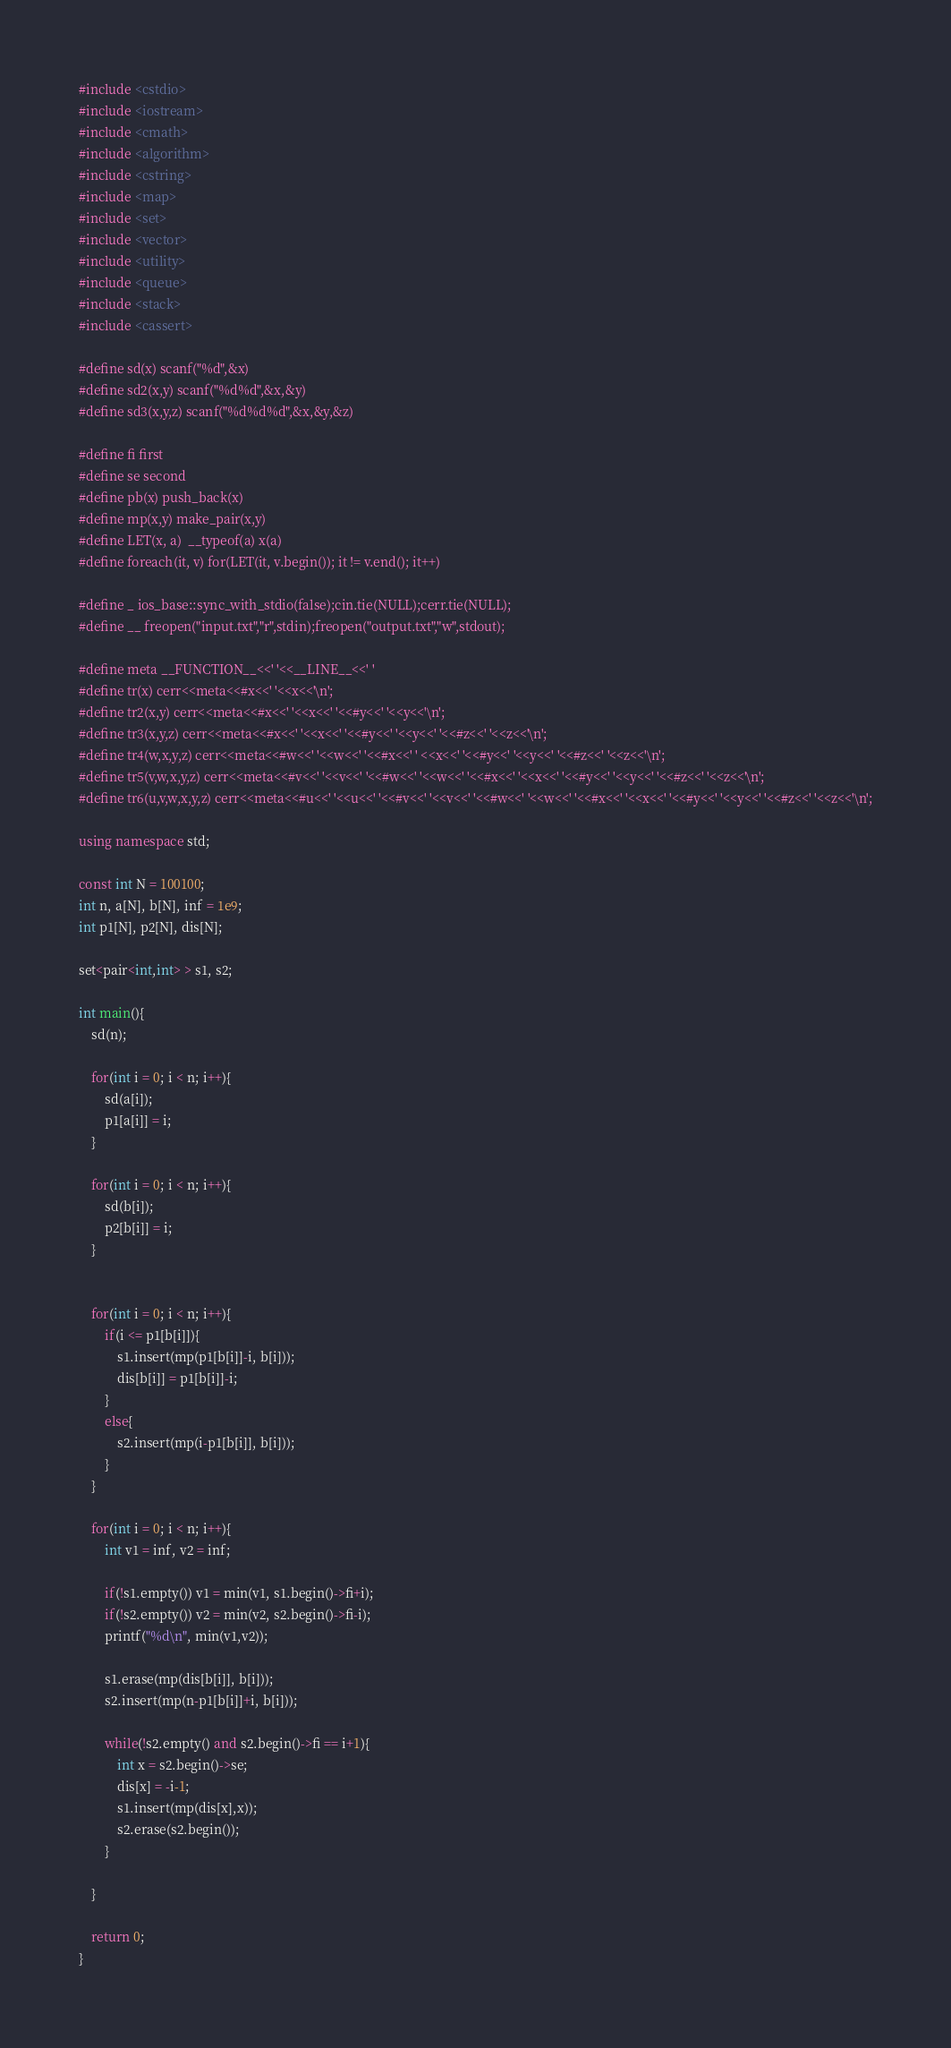<code> <loc_0><loc_0><loc_500><loc_500><_C++_>#include <cstdio>
#include <iostream>
#include <cmath>
#include <algorithm>
#include <cstring>
#include <map>
#include <set>
#include <vector>
#include <utility>
#include <queue>
#include <stack>
#include <cassert>

#define sd(x) scanf("%d",&x)
#define sd2(x,y) scanf("%d%d",&x,&y)
#define sd3(x,y,z) scanf("%d%d%d",&x,&y,&z)

#define fi first
#define se second
#define pb(x) push_back(x)
#define mp(x,y) make_pair(x,y)
#define LET(x, a)  __typeof(a) x(a)
#define foreach(it, v) for(LET(it, v.begin()); it != v.end(); it++)

#define _ ios_base::sync_with_stdio(false);cin.tie(NULL);cerr.tie(NULL);
#define __ freopen("input.txt","r",stdin);freopen("output.txt","w",stdout);

#define meta __FUNCTION__<<' '<<__LINE__<<' '
#define tr(x) cerr<<meta<<#x<<' '<<x<<'\n';
#define tr2(x,y) cerr<<meta<<#x<<' '<<x<<' '<<#y<<' '<<y<<'\n';
#define tr3(x,y,z) cerr<<meta<<#x<<' '<<x<<' '<<#y<<' '<<y<<' '<<#z<<' '<<z<<'\n';
#define tr4(w,x,y,z) cerr<<meta<<#w<<' '<<w<<' '<<#x<<' ' <<x<<' '<<#y<<' '<<y<<' '<<#z<<' '<<z<<'\n';
#define tr5(v,w,x,y,z) cerr<<meta<<#v<<' '<<v<<' '<<#w<<' '<<w<<' '<<#x<<' '<<x<<' '<<#y<<' '<<y<<' '<<#z<<' '<<z<<'\n';
#define tr6(u,v,w,x,y,z) cerr<<meta<<#u<<' '<<u<<' '<<#v<<' '<<v<<' '<<#w<<' '<<w<<' '<<#x<<' '<<x<<' '<<#y<<' '<<y<<' '<<#z<<' '<<z<<'\n';

using namespace std;

const int N = 100100;
int n, a[N], b[N], inf = 1e9;
int p1[N], p2[N], dis[N];

set<pair<int,int> > s1, s2;

int main(){
	sd(n);
	
	for(int i = 0; i < n; i++){
		sd(a[i]);
		p1[a[i]] = i;
	}
	
	for(int i = 0; i < n; i++){
		sd(b[i]);
		p2[b[i]] = i;
	}
	
		
	for(int i = 0; i < n; i++){
		if(i <= p1[b[i]]){
			s1.insert(mp(p1[b[i]]-i, b[i]));	
			dis[b[i]] = p1[b[i]]-i;
		}
		else{
			s2.insert(mp(i-p1[b[i]], b[i]));
		}
	}
	
	for(int i = 0; i < n; i++){
		int v1 = inf, v2 = inf;
		
		if(!s1.empty()) v1 = min(v1, s1.begin()->fi+i);
		if(!s2.empty()) v2 = min(v2, s2.begin()->fi-i);
		printf("%d\n", min(v1,v2));
		
		s1.erase(mp(dis[b[i]], b[i]));
		s2.insert(mp(n-p1[b[i]]+i, b[i]));
		
		while(!s2.empty() and s2.begin()->fi == i+1){
			int x = s2.begin()->se;
			dis[x] = -i-1;
			s1.insert(mp(dis[x],x));
			s2.erase(s2.begin());
		}
		
	}
	
	return 0;
}
</code> 